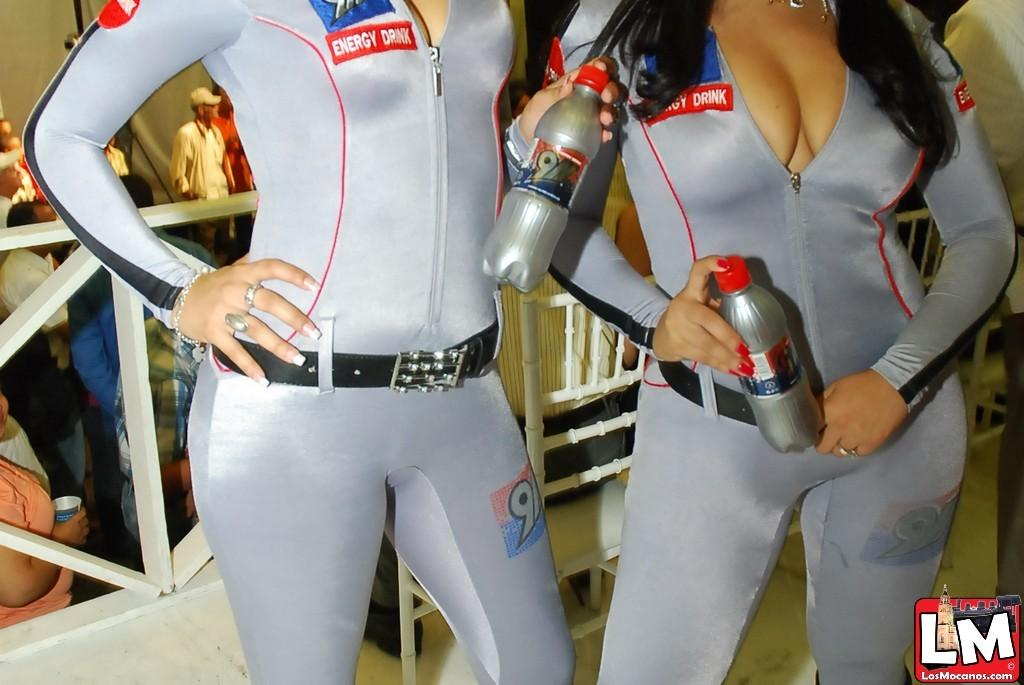<image>
Offer a succinct explanation of the picture presented. Two attractive females promoting 911 Energy Drink are brought to you by www.LosMocanos.com. 